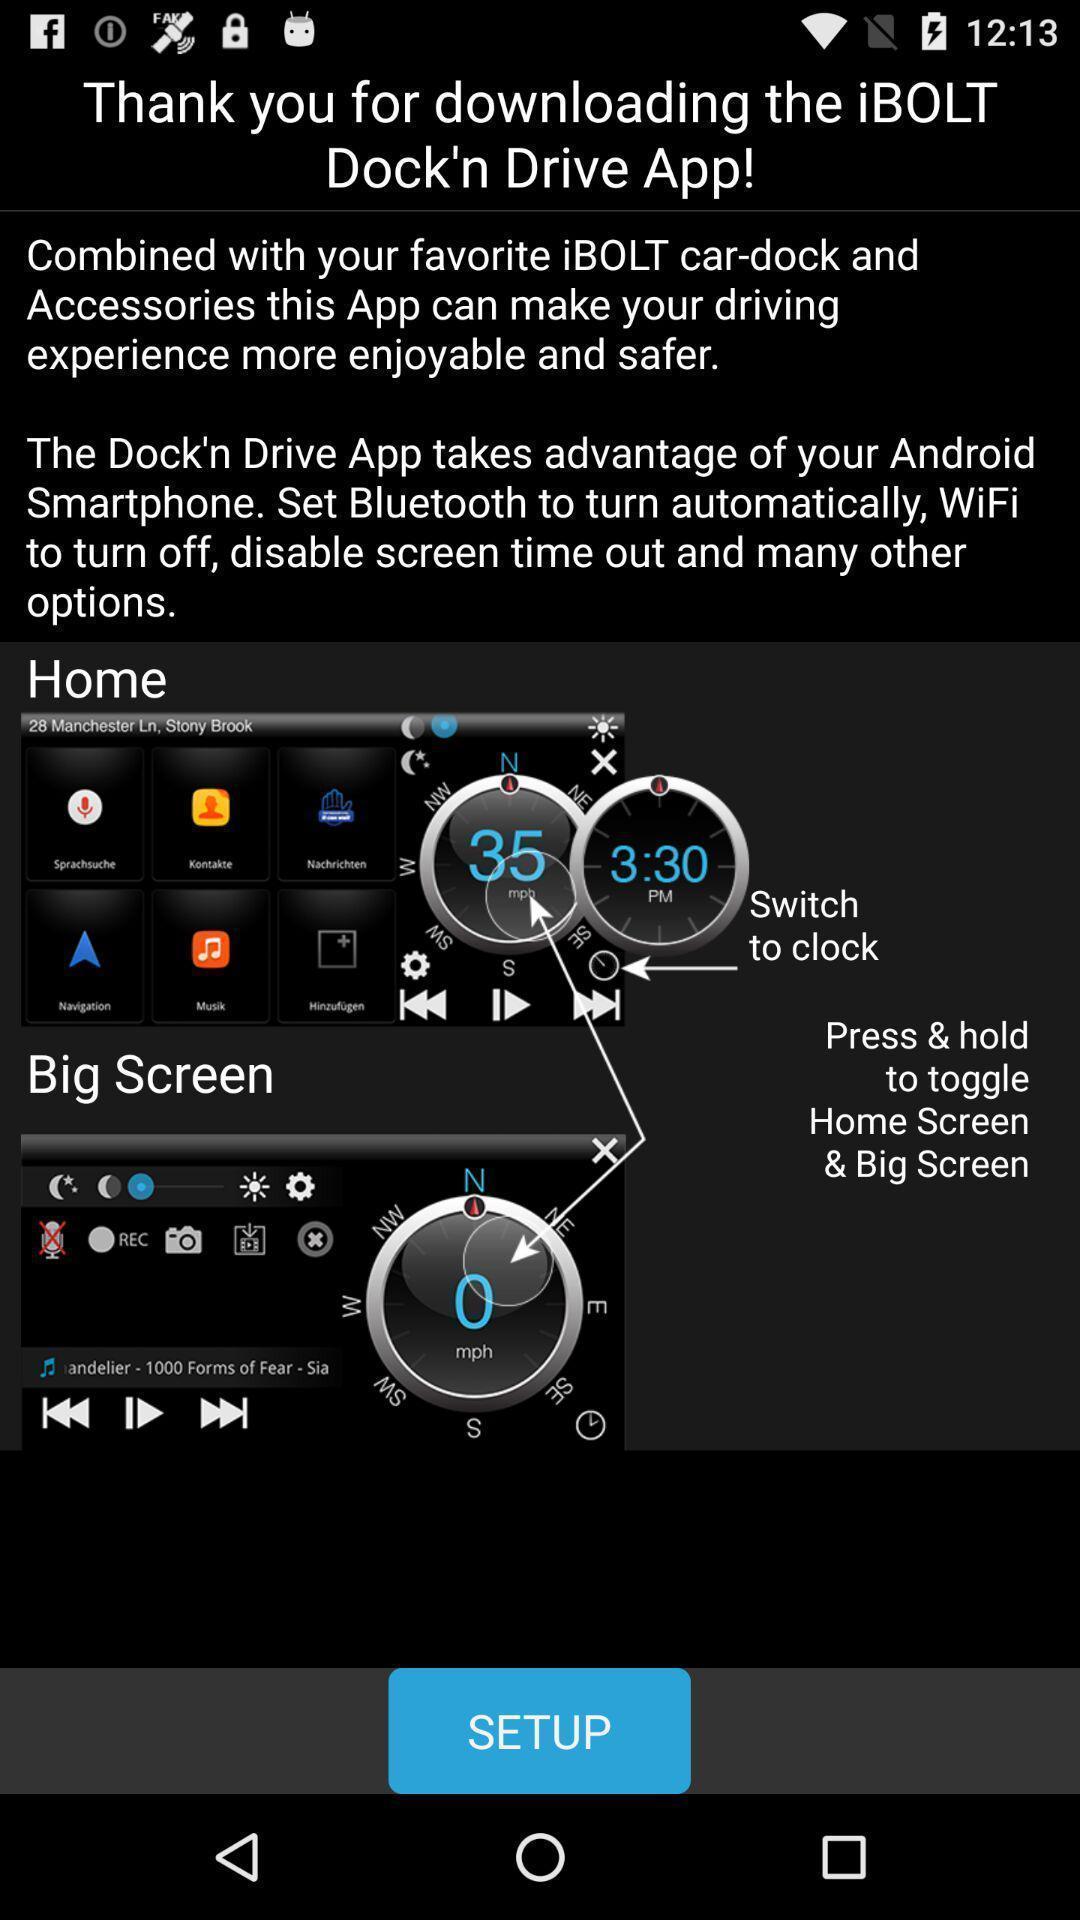Please provide a description for this image. Screen displaying the page of a driving app. 